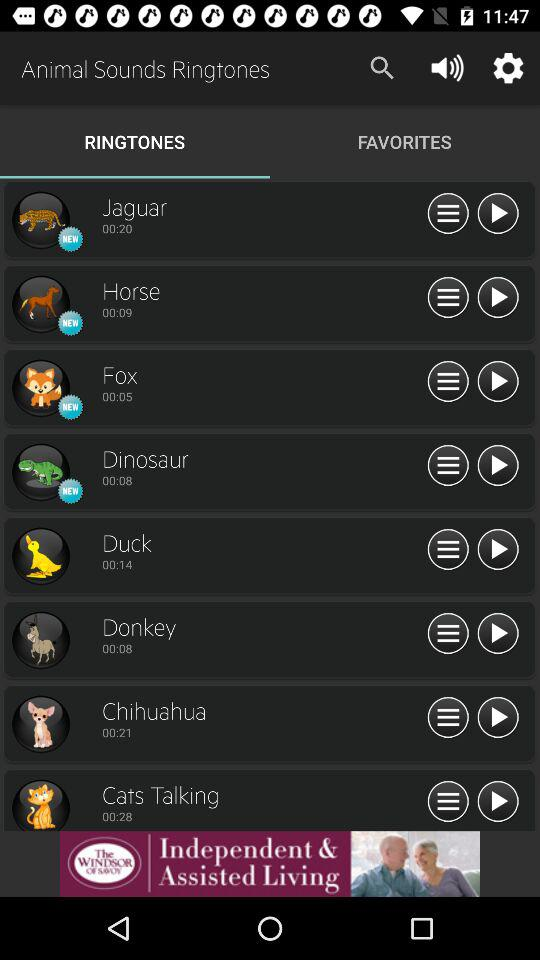How many more seconds of audio does the song 'Cats Talking' have than the song 'Duck'?
Answer the question using a single word or phrase. 14 